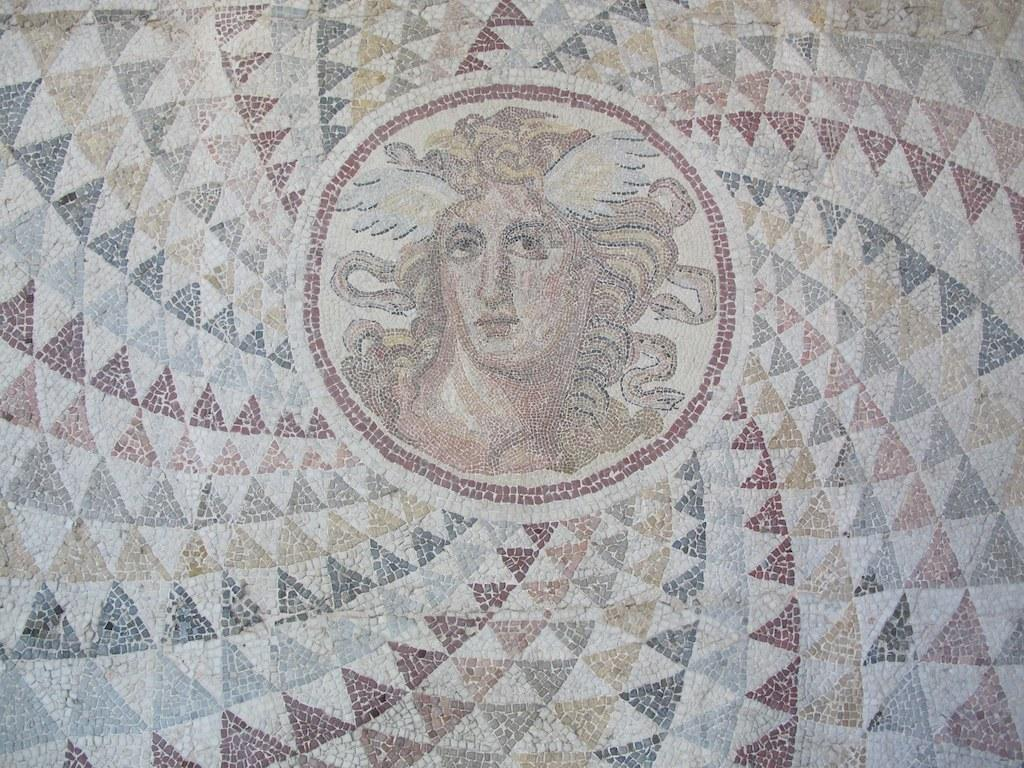What type of pattern is created on the floor in the image? There are small stones arranged in a mosaic on the floor. Can you describe the person's face in the image? Unfortunately, the facts provided do not mention a person's face in the image. What advice does the person in the image give about their favorite hobbies? There is no person present in the image, so no advice or discussion about hobbies can be observed. 